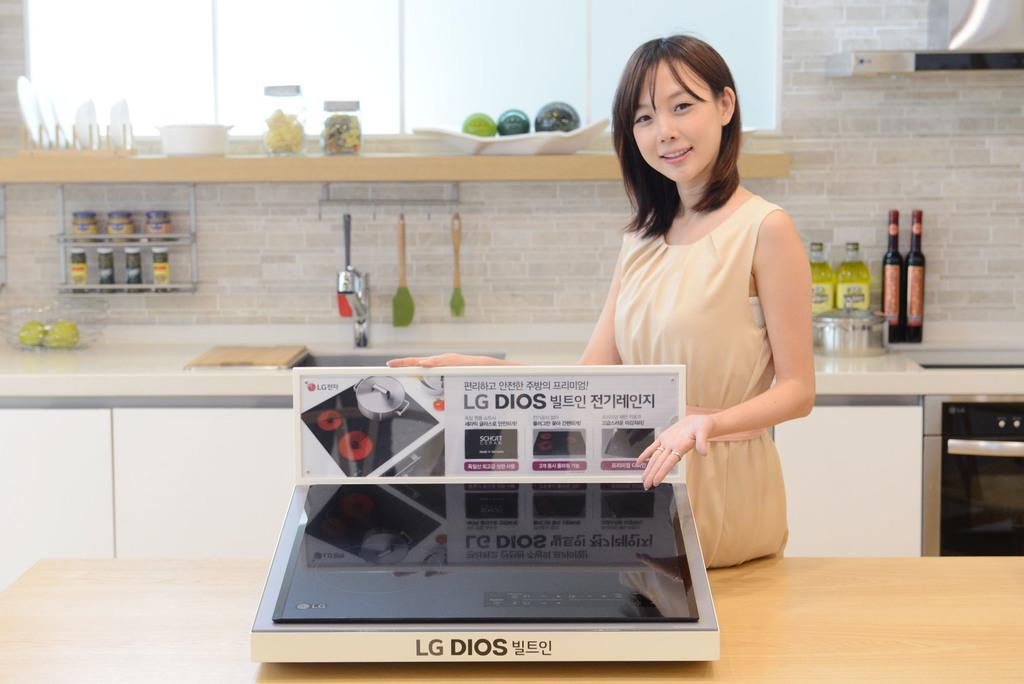<image>
Describe the image concisely. A woman displays the LG Dios stovetop in a modern kitchen. 